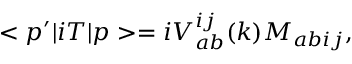<formula> <loc_0><loc_0><loc_500><loc_500>< p ^ { \prime } | i T | p > = i V _ { a b } ^ { i j } ( k ) M _ { a b i j } ,</formula> 